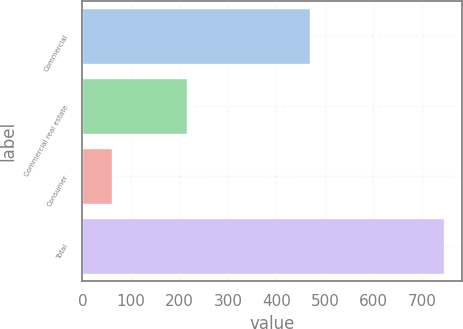Convert chart. <chart><loc_0><loc_0><loc_500><loc_500><bar_chart><fcel>Commercial<fcel>Commercial real estate<fcel>Consumer<fcel>Total<nl><fcel>469<fcel>216<fcel>61<fcel>746<nl></chart> 